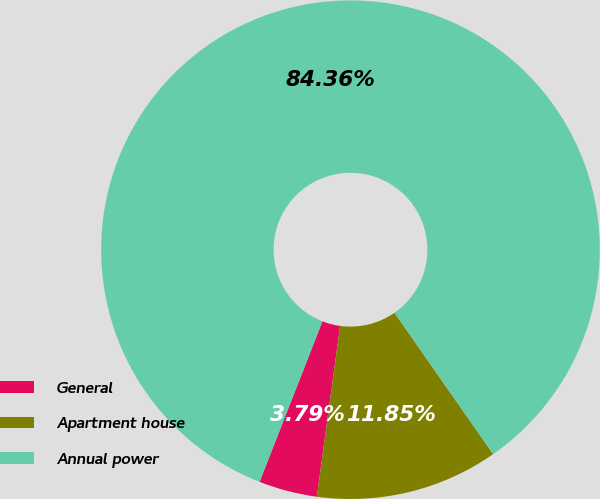Convert chart to OTSL. <chart><loc_0><loc_0><loc_500><loc_500><pie_chart><fcel>General<fcel>Apartment house<fcel>Annual power<nl><fcel>3.79%<fcel>11.85%<fcel>84.36%<nl></chart> 